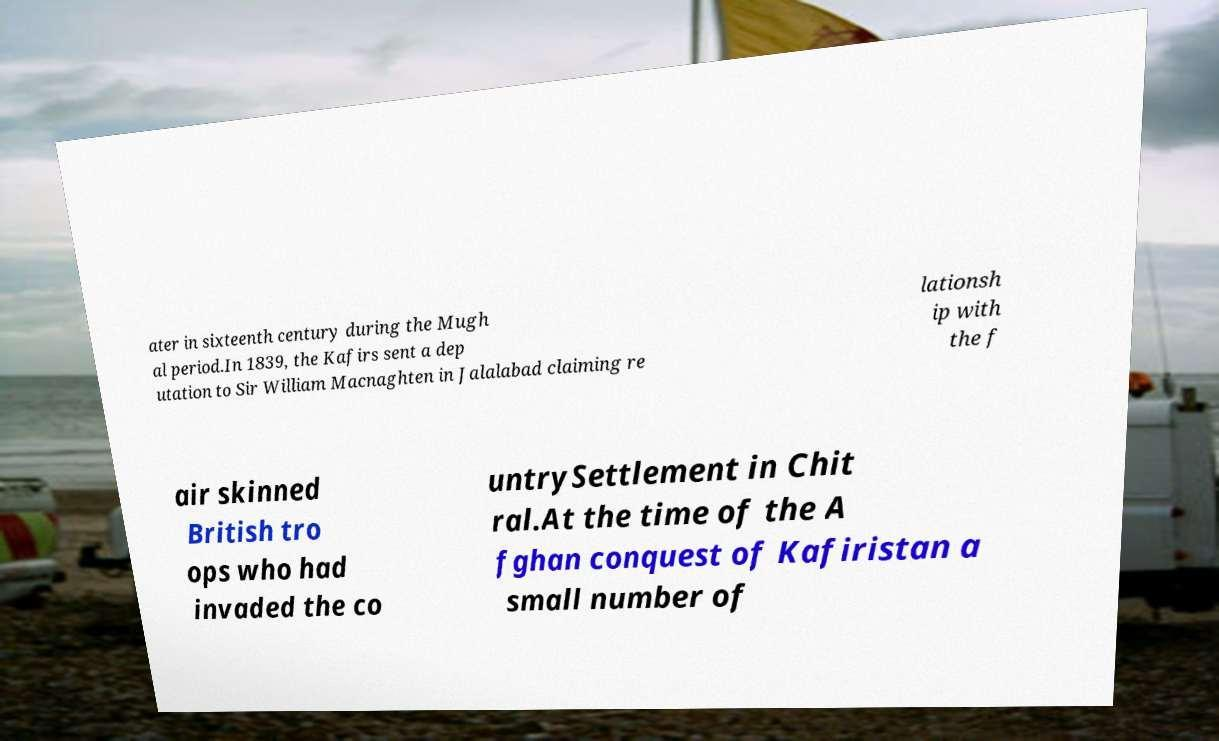Could you assist in decoding the text presented in this image and type it out clearly? ater in sixteenth century during the Mugh al period.In 1839, the Kafirs sent a dep utation to Sir William Macnaghten in Jalalabad claiming re lationsh ip with the f air skinned British tro ops who had invaded the co untrySettlement in Chit ral.At the time of the A fghan conquest of Kafiristan a small number of 